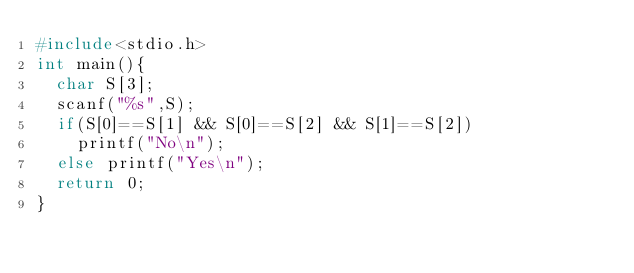<code> <loc_0><loc_0><loc_500><loc_500><_C_>#include<stdio.h>
int main(){
  char S[3];
  scanf("%s",S);
  if(S[0]==S[1] && S[0]==S[2] && S[1]==S[2])
    printf("No\n");
  else printf("Yes\n");
  return 0;
}</code> 